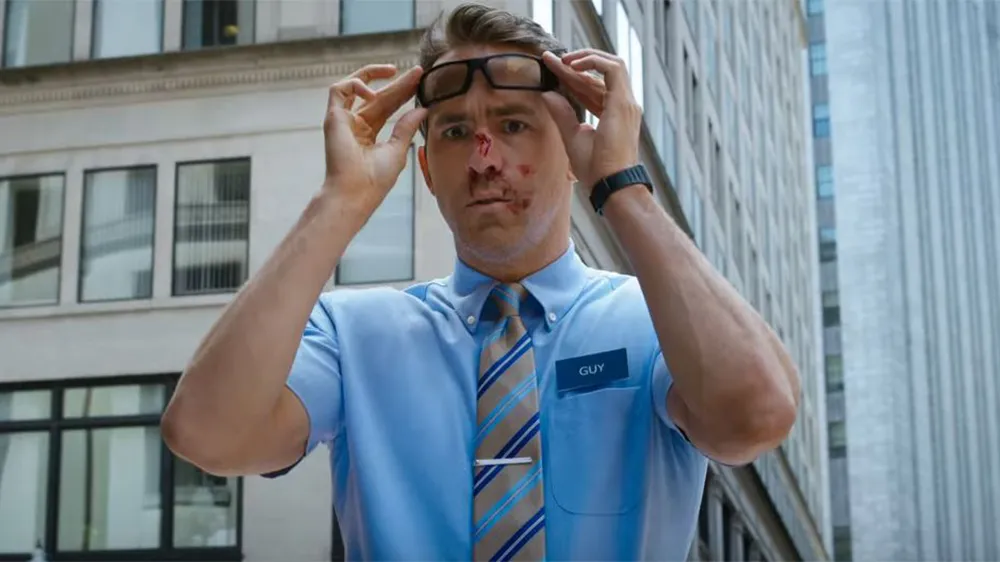Write a detailed description of the given image. The image shows a man in a light blue work uniform with a 'Guy' name tag. He is adjusting his glasses with both hands, expressing a look of surprise or confusion. Notably, there is a visible streak of blood on his nose, suggesting he might have encountered some mishap. Behind him, a large building looms, indicating an urban setting. His attire and the overall scenario hint at a narrative, possibly from a film or a series, involving this character in an unexpected or dramatic situation. 